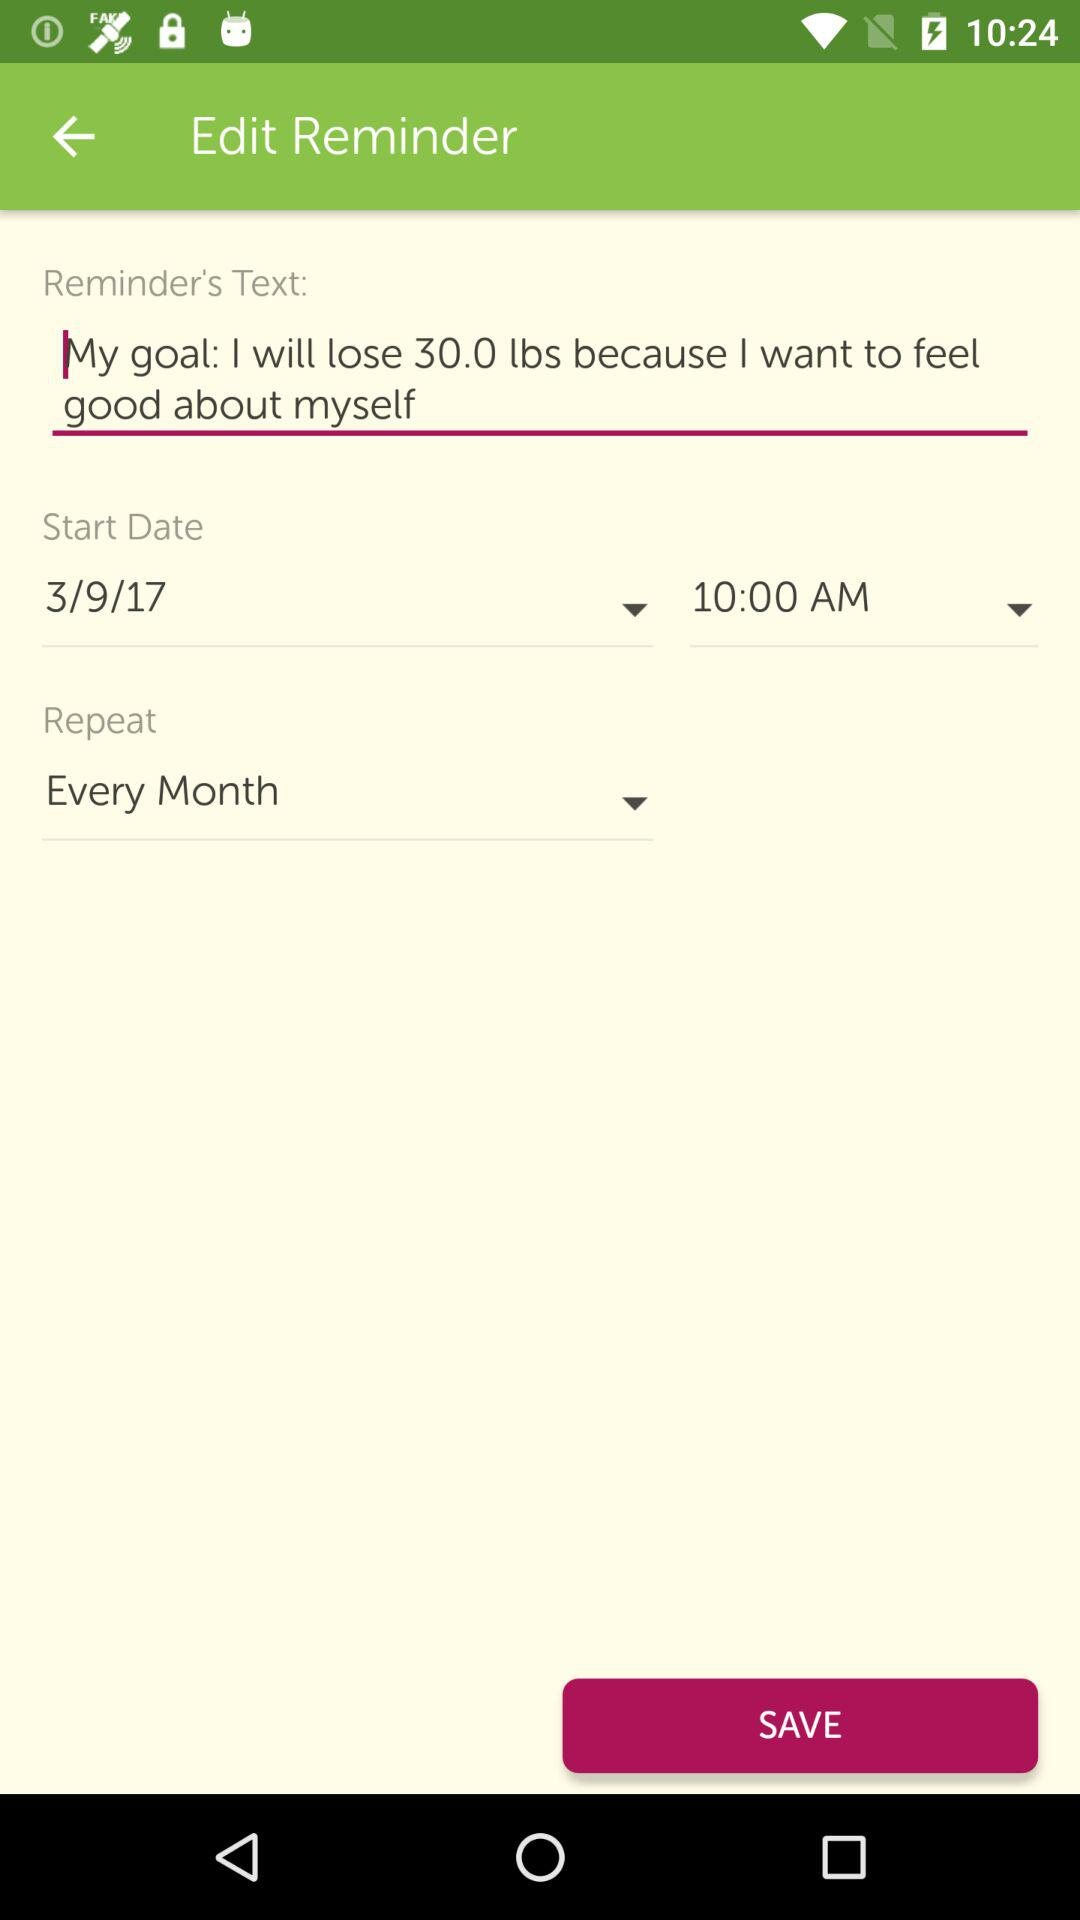What is the selected time? The selected time is 10:00 AM. 